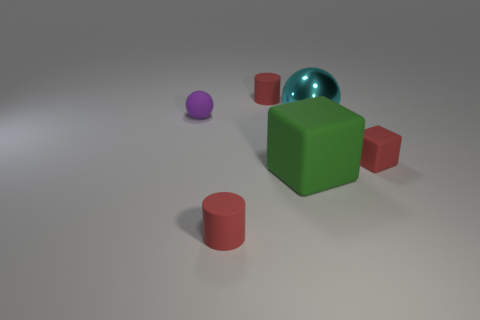What is the tiny red thing that is on the left side of the metallic thing and in front of the large cyan object made of?
Your answer should be compact. Rubber. What is the material of the big cyan thing that is the same shape as the purple matte thing?
Your response must be concise. Metal. Is the shape of the small red matte object that is on the right side of the large cyan shiny sphere the same as the large object in front of the big cyan thing?
Offer a very short reply. Yes. What is the shape of the rubber thing that is in front of the cyan metal sphere and behind the large green matte thing?
Give a very brief answer. Cube. What is the color of the small object on the left side of the small cylinder that is in front of the sphere on the left side of the cyan ball?
Your response must be concise. Purple. Do the tiny matte cylinder behind the tiny red block and the tiny rubber object to the right of the big metallic sphere have the same color?
Your response must be concise. Yes. There is a sphere that is on the right side of the green block; how many cyan spheres are behind it?
Offer a very short reply. 0. Is there a large blue thing?
Make the answer very short. No. How many other things are the same color as the small ball?
Your answer should be compact. 0. Is the number of big purple cylinders less than the number of big cyan metallic objects?
Offer a very short reply. Yes. 